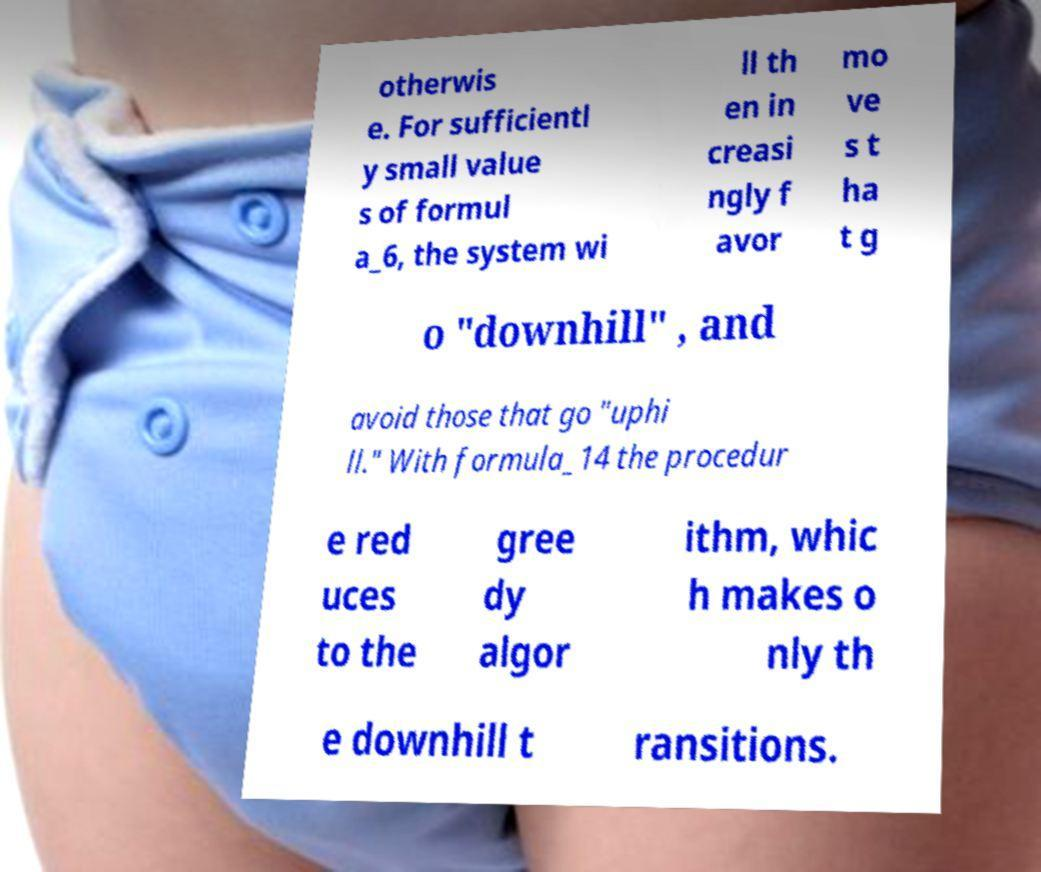There's text embedded in this image that I need extracted. Can you transcribe it verbatim? otherwis e. For sufficientl y small value s of formul a_6, the system wi ll th en in creasi ngly f avor mo ve s t ha t g o "downhill" , and avoid those that go "uphi ll." With formula_14 the procedur e red uces to the gree dy algor ithm, whic h makes o nly th e downhill t ransitions. 